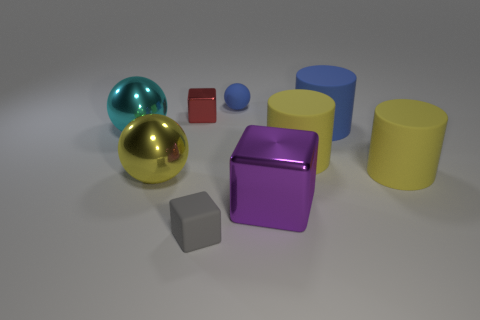Does the metallic block left of the purple metallic thing have the same size as the metal cube in front of the red cube?
Ensure brevity in your answer.  No. What number of things are small red objects or large purple metal objects?
Offer a very short reply. 2. There is a big sphere that is left of the sphere in front of the big cyan sphere; what is its material?
Make the answer very short. Metal. What number of yellow shiny things have the same shape as the small gray thing?
Give a very brief answer. 0. Are there any small metallic balls of the same color as the matte sphere?
Ensure brevity in your answer.  No. How many objects are either tiny rubber objects that are behind the large cyan metallic object or objects that are left of the yellow metal sphere?
Your response must be concise. 2. Are there any purple shiny objects on the right side of the blue object on the right side of the purple block?
Make the answer very short. No. There is a purple object that is the same size as the cyan metal ball; what shape is it?
Provide a succinct answer. Cube. What number of things are either metal things to the left of the tiny blue object or yellow balls?
Offer a very short reply. 3. How many other things are there of the same material as the large cyan thing?
Your answer should be very brief. 3. 